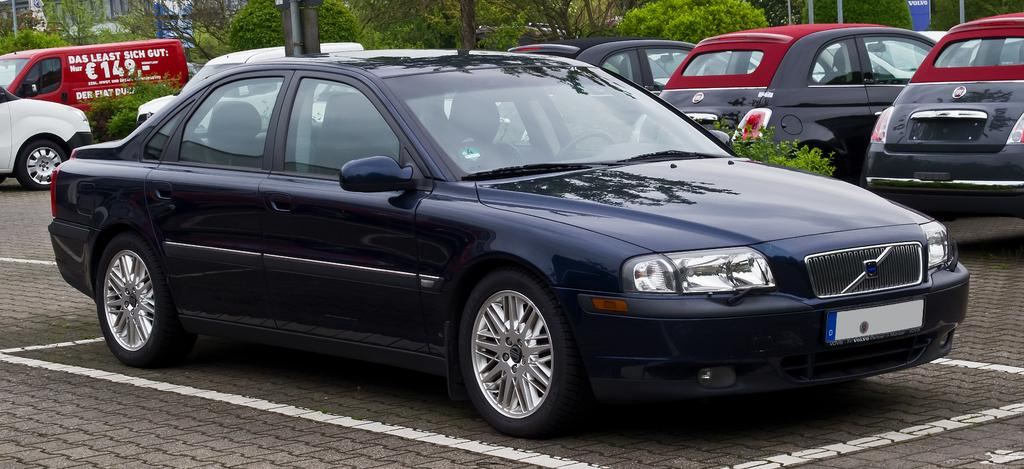What can be seen in the image related to transportation? There are vehicles parked in the image. How are the vehicles arranged in the image? The vehicles are parked in one place. What can be seen in the background of the image? There are trees visible in the background of the image. Are there any plants present in the image? Yes, there are potted plants in the image. What type of pen is being used to write on the vehicles in the image? There is no pen or writing visible on the vehicles in the image. Can you tell me how many toothbrushes are placed on top of the vehicles in the image? There are no toothbrushes present on top of the vehicles in the image. 